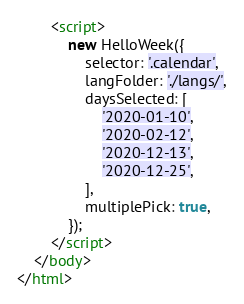<code> <loc_0><loc_0><loc_500><loc_500><_HTML_>        <script>
            new HelloWeek({
                selector: '.calendar',
                langFolder: './langs/',
                daysSelected: [
                    '2020-01-10',
                    '2020-02-12',
                    '2020-12-13',
                    '2020-12-25',
                ],
                multiplePick: true,
            });
        </script>
    </body>
</html>
</code> 